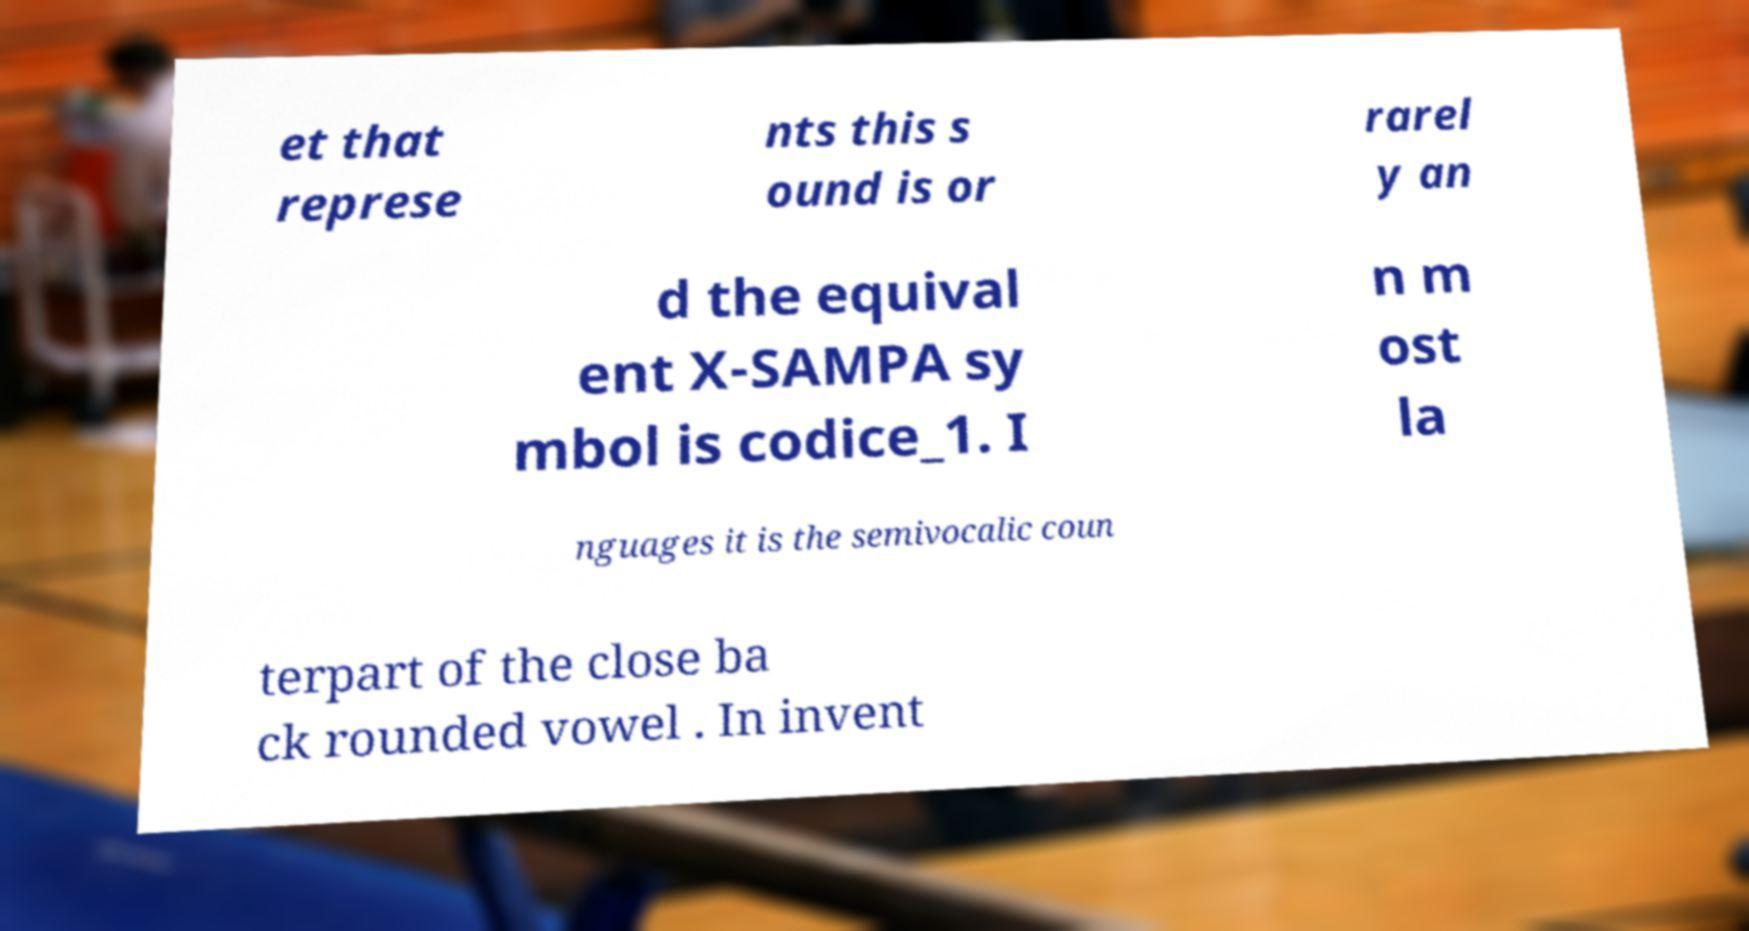Could you extract and type out the text from this image? et that represe nts this s ound is or rarel y an d the equival ent X-SAMPA sy mbol is codice_1. I n m ost la nguages it is the semivocalic coun terpart of the close ba ck rounded vowel . In invent 